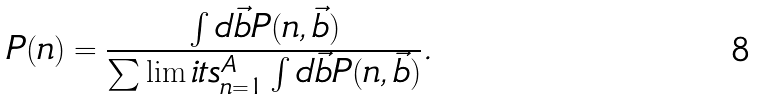<formula> <loc_0><loc_0><loc_500><loc_500>P ( n ) = \frac { \int d \vec { b } P ( n , \vec { b } ) } { \sum \lim i t s _ { n = 1 } ^ { A } \int d \vec { b } P ( n , \vec { b } ) } .</formula> 